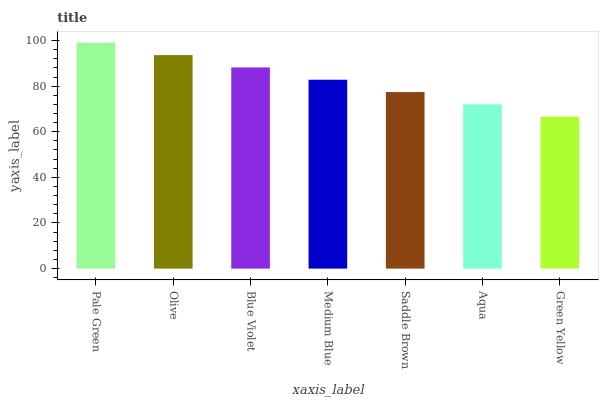Is Green Yellow the minimum?
Answer yes or no. Yes. Is Pale Green the maximum?
Answer yes or no. Yes. Is Olive the minimum?
Answer yes or no. No. Is Olive the maximum?
Answer yes or no. No. Is Pale Green greater than Olive?
Answer yes or no. Yes. Is Olive less than Pale Green?
Answer yes or no. Yes. Is Olive greater than Pale Green?
Answer yes or no. No. Is Pale Green less than Olive?
Answer yes or no. No. Is Medium Blue the high median?
Answer yes or no. Yes. Is Medium Blue the low median?
Answer yes or no. Yes. Is Pale Green the high median?
Answer yes or no. No. Is Pale Green the low median?
Answer yes or no. No. 